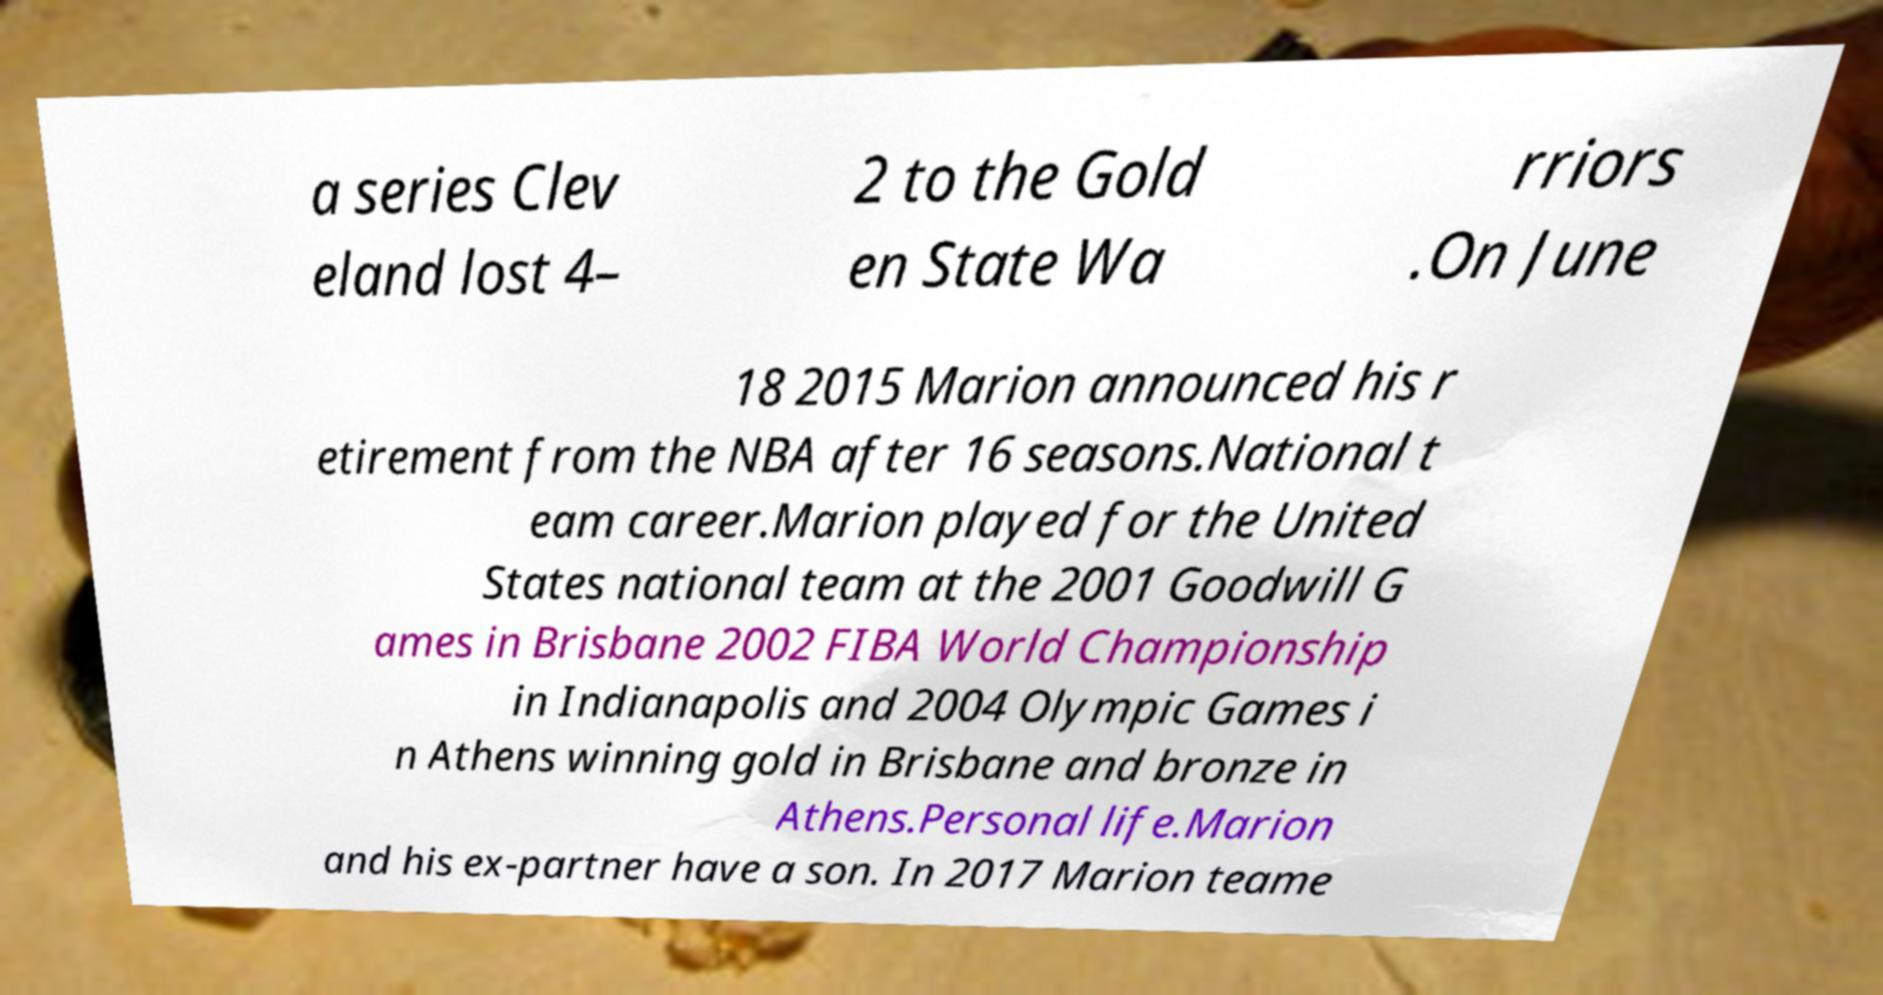Could you extract and type out the text from this image? a series Clev eland lost 4– 2 to the Gold en State Wa rriors .On June 18 2015 Marion announced his r etirement from the NBA after 16 seasons.National t eam career.Marion played for the United States national team at the 2001 Goodwill G ames in Brisbane 2002 FIBA World Championship in Indianapolis and 2004 Olympic Games i n Athens winning gold in Brisbane and bronze in Athens.Personal life.Marion and his ex-partner have a son. In 2017 Marion teame 